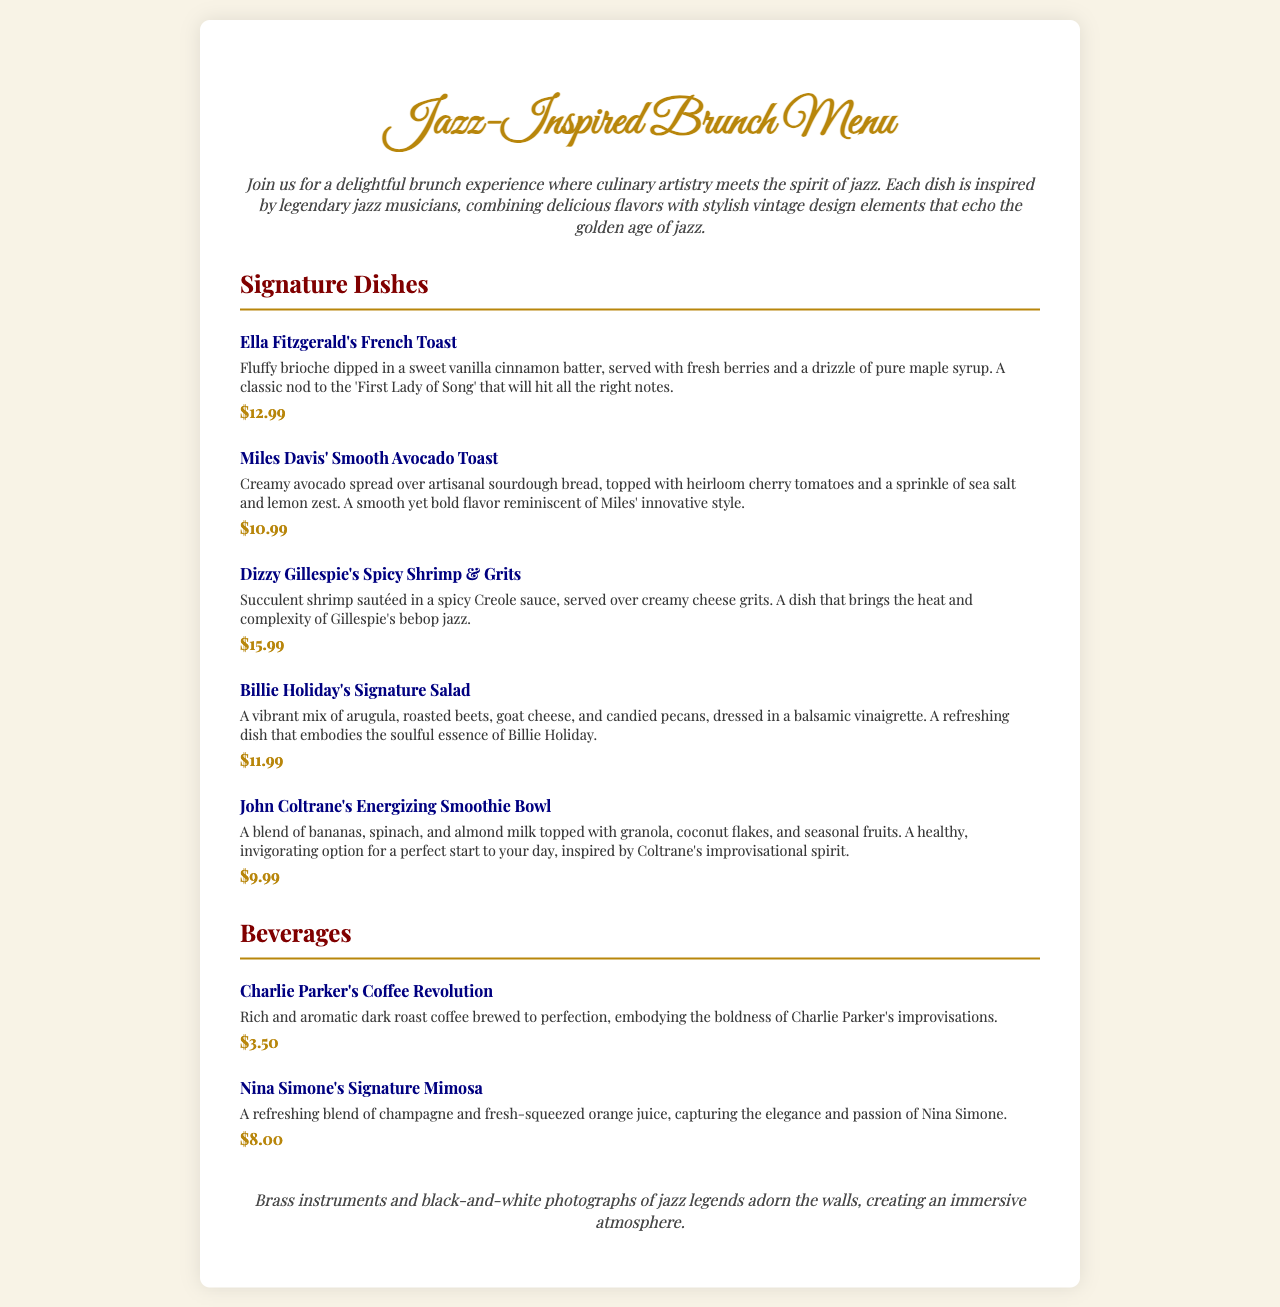what is the price of Ella Fitzgerald's French Toast? The price is stated clearly next to the dish description.
Answer: $12.99 which dish is inspired by Miles Davis? The dish inspired by Miles Davis is mentioned by name in the document under the signature dishes section.
Answer: Miles Davis' Smooth Avocado Toast how many signature dishes are listed in the menu? The total number of dishes can be counted from the signature dishes section in the document.
Answer: Five what is the main ingredient in John Coltrane's Energizing Smoothie Bowl? The main ingredient is highlighted in the description of the smoothie bowl.
Answer: Bananas which beverage is described as capturing the elegance of Nina Simone? The beverage that embodies Nina Simone's elegance is specifically named in the beverages section.
Answer: Nina Simone's Signature Mimosa what type of atmosphere does the restaurant aim to create? The document describes the decorative elements intended to create a specific ambiance.
Answer: Immersive atmosphere what is the flavor profile of Dizzy Gillespie's dish? The dish's description includes specific adjectives that help define its flavor profile.
Answer: Spicy how is the coffee named after Charlie Parker described? The description provides details on the characteristics of Charlie Parker's coffee.
Answer: Rich and aromatic 